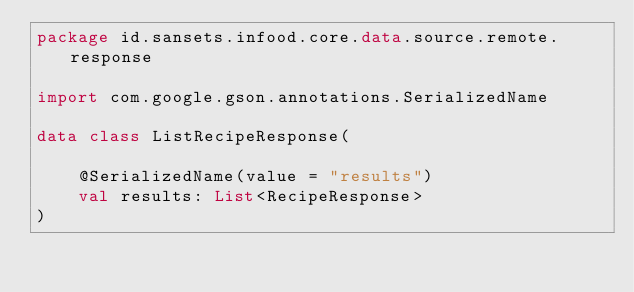Convert code to text. <code><loc_0><loc_0><loc_500><loc_500><_Kotlin_>package id.sansets.infood.core.data.source.remote.response

import com.google.gson.annotations.SerializedName

data class ListRecipeResponse(

    @SerializedName(value = "results")
    val results: List<RecipeResponse>
)</code> 